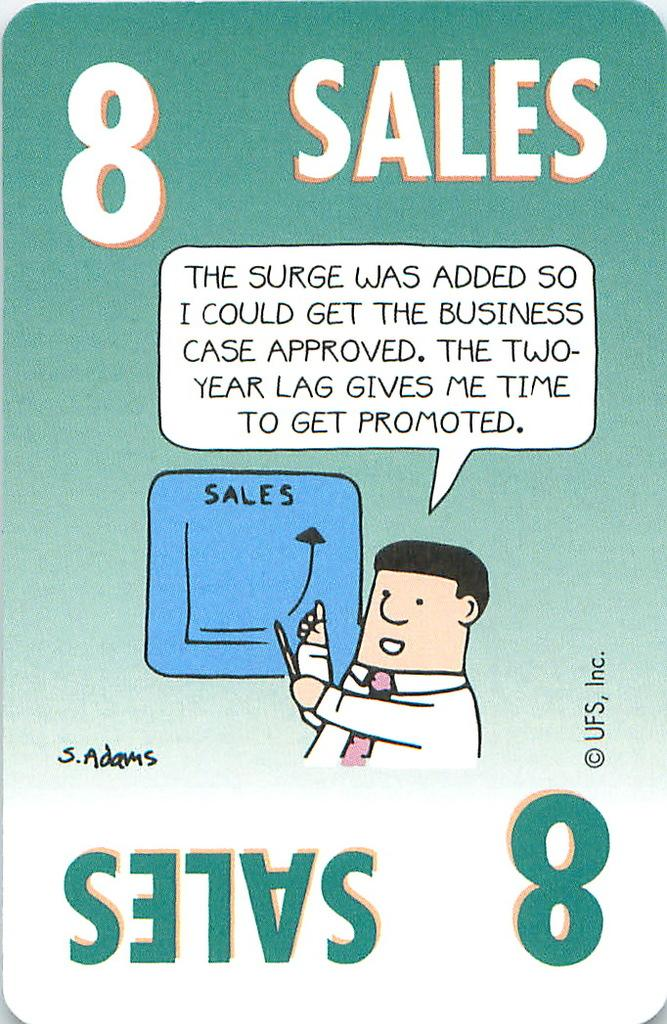What type of poster is visible in the image? There is a digital poster in the image. What can be found on the digital poster? The digital poster contains text and a picture. Are there any fairies visible in the image? No, there are no fairies present in the image. What type of currency is mentioned in the text on the digital poster? The provided facts do not mention any specific currency or cent; the text on the digital poster is not described in detail. 